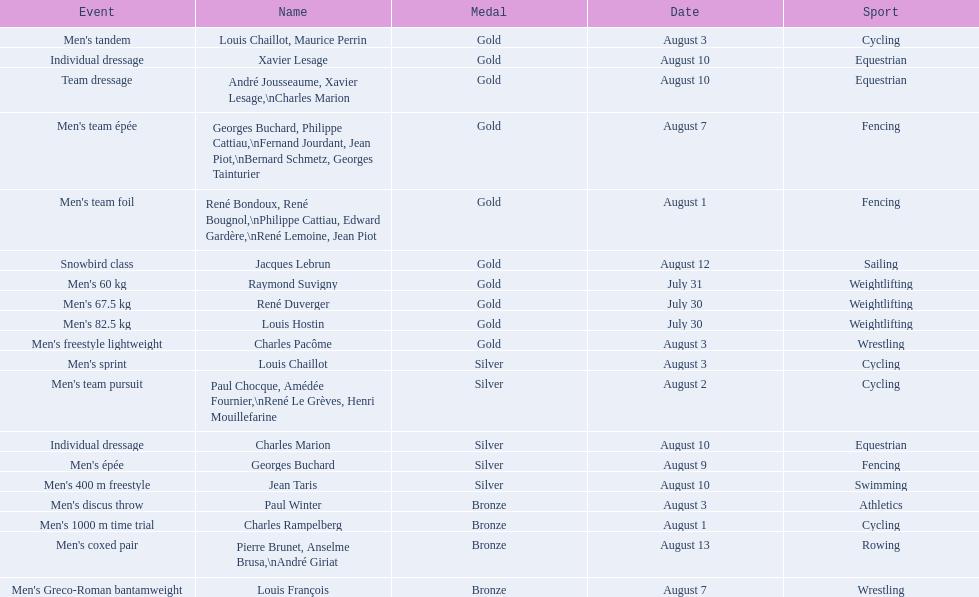How many total gold medals were won by weightlifting? 3. 